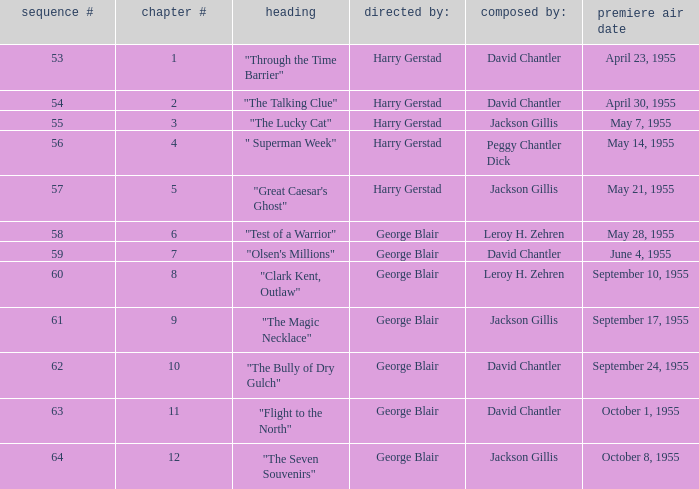Which Season originally aired on September 17, 1955 9.0. 